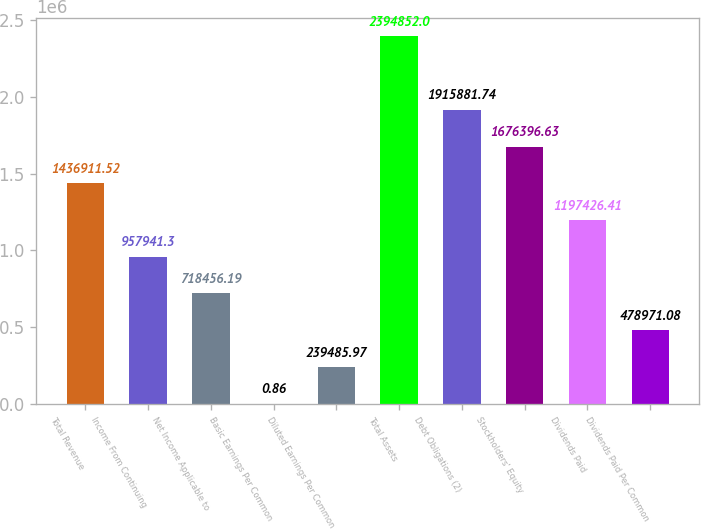Convert chart. <chart><loc_0><loc_0><loc_500><loc_500><bar_chart><fcel>Total Revenue<fcel>Income From Continuing<fcel>Net Income Applicable to<fcel>Basic Earnings Per Common<fcel>Diluted Earnings Per Common<fcel>Total Assets<fcel>Debt Obligations (2)<fcel>Stockholders' Equity<fcel>Dividends Paid<fcel>Dividends Paid Per Common<nl><fcel>1.43691e+06<fcel>957941<fcel>718456<fcel>0.86<fcel>239486<fcel>2.39485e+06<fcel>1.91588e+06<fcel>1.6764e+06<fcel>1.19743e+06<fcel>478971<nl></chart> 